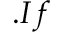Convert formula to latex. <formula><loc_0><loc_0><loc_500><loc_500>. I f</formula> 